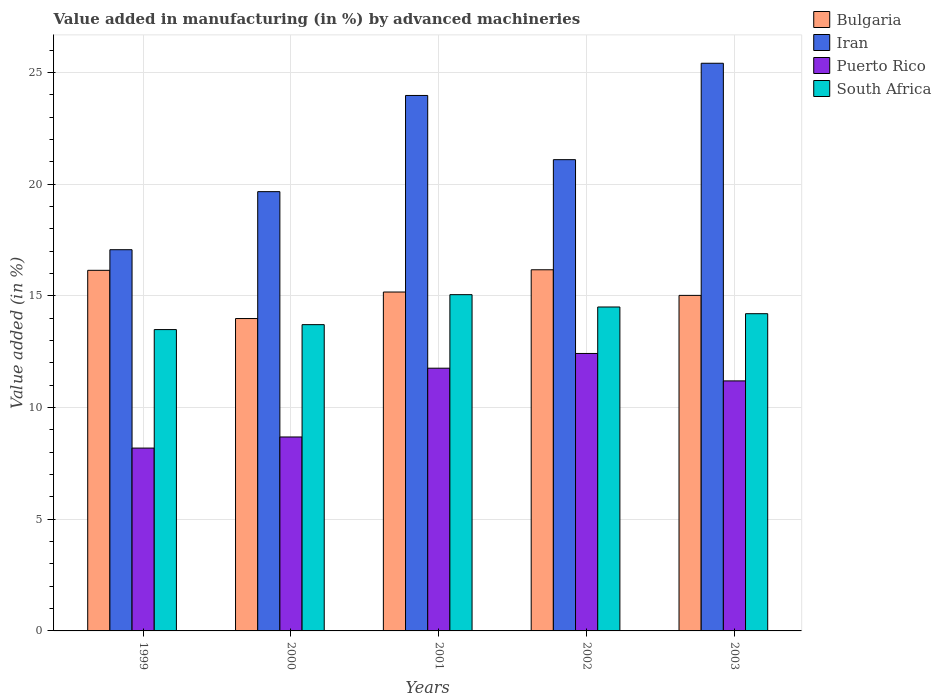How many different coloured bars are there?
Your answer should be very brief. 4. What is the label of the 5th group of bars from the left?
Provide a succinct answer. 2003. In how many cases, is the number of bars for a given year not equal to the number of legend labels?
Provide a short and direct response. 0. What is the percentage of value added in manufacturing by advanced machineries in Iran in 2002?
Ensure brevity in your answer.  21.1. Across all years, what is the maximum percentage of value added in manufacturing by advanced machineries in South Africa?
Ensure brevity in your answer.  15.05. Across all years, what is the minimum percentage of value added in manufacturing by advanced machineries in Puerto Rico?
Your answer should be compact. 8.19. In which year was the percentage of value added in manufacturing by advanced machineries in South Africa minimum?
Give a very brief answer. 1999. What is the total percentage of value added in manufacturing by advanced machineries in Puerto Rico in the graph?
Give a very brief answer. 52.25. What is the difference between the percentage of value added in manufacturing by advanced machineries in South Africa in 2001 and that in 2003?
Offer a very short reply. 0.85. What is the difference between the percentage of value added in manufacturing by advanced machineries in Iran in 2000 and the percentage of value added in manufacturing by advanced machineries in South Africa in 1999?
Provide a succinct answer. 6.18. What is the average percentage of value added in manufacturing by advanced machineries in South Africa per year?
Provide a succinct answer. 14.19. In the year 2000, what is the difference between the percentage of value added in manufacturing by advanced machineries in South Africa and percentage of value added in manufacturing by advanced machineries in Puerto Rico?
Your response must be concise. 5.03. What is the ratio of the percentage of value added in manufacturing by advanced machineries in Iran in 2000 to that in 2001?
Offer a very short reply. 0.82. Is the percentage of value added in manufacturing by advanced machineries in Puerto Rico in 1999 less than that in 2003?
Your response must be concise. Yes. What is the difference between the highest and the second highest percentage of value added in manufacturing by advanced machineries in South Africa?
Your response must be concise. 0.55. What is the difference between the highest and the lowest percentage of value added in manufacturing by advanced machineries in Bulgaria?
Keep it short and to the point. 2.18. In how many years, is the percentage of value added in manufacturing by advanced machineries in Puerto Rico greater than the average percentage of value added in manufacturing by advanced machineries in Puerto Rico taken over all years?
Your response must be concise. 3. Is the sum of the percentage of value added in manufacturing by advanced machineries in Iran in 2000 and 2002 greater than the maximum percentage of value added in manufacturing by advanced machineries in Puerto Rico across all years?
Provide a succinct answer. Yes. What does the 3rd bar from the left in 2001 represents?
Offer a very short reply. Puerto Rico. What does the 1st bar from the right in 1999 represents?
Provide a short and direct response. South Africa. Is it the case that in every year, the sum of the percentage of value added in manufacturing by advanced machineries in Iran and percentage of value added in manufacturing by advanced machineries in Bulgaria is greater than the percentage of value added in manufacturing by advanced machineries in South Africa?
Provide a short and direct response. Yes. Are all the bars in the graph horizontal?
Offer a terse response. No. Are the values on the major ticks of Y-axis written in scientific E-notation?
Provide a short and direct response. No. Where does the legend appear in the graph?
Give a very brief answer. Top right. What is the title of the graph?
Your response must be concise. Value added in manufacturing (in %) by advanced machineries. Does "Mauritius" appear as one of the legend labels in the graph?
Give a very brief answer. No. What is the label or title of the X-axis?
Ensure brevity in your answer.  Years. What is the label or title of the Y-axis?
Provide a succinct answer. Value added (in %). What is the Value added (in %) in Bulgaria in 1999?
Your answer should be compact. 16.14. What is the Value added (in %) of Iran in 1999?
Provide a short and direct response. 17.07. What is the Value added (in %) in Puerto Rico in 1999?
Offer a terse response. 8.19. What is the Value added (in %) of South Africa in 1999?
Your response must be concise. 13.49. What is the Value added (in %) of Bulgaria in 2000?
Offer a very short reply. 13.99. What is the Value added (in %) of Iran in 2000?
Your response must be concise. 19.67. What is the Value added (in %) of Puerto Rico in 2000?
Provide a short and direct response. 8.68. What is the Value added (in %) of South Africa in 2000?
Offer a very short reply. 13.71. What is the Value added (in %) in Bulgaria in 2001?
Offer a terse response. 15.17. What is the Value added (in %) in Iran in 2001?
Provide a short and direct response. 23.97. What is the Value added (in %) in Puerto Rico in 2001?
Make the answer very short. 11.76. What is the Value added (in %) of South Africa in 2001?
Give a very brief answer. 15.05. What is the Value added (in %) in Bulgaria in 2002?
Your response must be concise. 16.17. What is the Value added (in %) of Iran in 2002?
Make the answer very short. 21.1. What is the Value added (in %) of Puerto Rico in 2002?
Provide a succinct answer. 12.42. What is the Value added (in %) in South Africa in 2002?
Provide a succinct answer. 14.5. What is the Value added (in %) in Bulgaria in 2003?
Make the answer very short. 15.02. What is the Value added (in %) of Iran in 2003?
Give a very brief answer. 25.41. What is the Value added (in %) of Puerto Rico in 2003?
Keep it short and to the point. 11.19. What is the Value added (in %) of South Africa in 2003?
Keep it short and to the point. 14.2. Across all years, what is the maximum Value added (in %) in Bulgaria?
Give a very brief answer. 16.17. Across all years, what is the maximum Value added (in %) of Iran?
Give a very brief answer. 25.41. Across all years, what is the maximum Value added (in %) in Puerto Rico?
Your response must be concise. 12.42. Across all years, what is the maximum Value added (in %) in South Africa?
Ensure brevity in your answer.  15.05. Across all years, what is the minimum Value added (in %) of Bulgaria?
Offer a terse response. 13.99. Across all years, what is the minimum Value added (in %) in Iran?
Keep it short and to the point. 17.07. Across all years, what is the minimum Value added (in %) in Puerto Rico?
Provide a short and direct response. 8.19. Across all years, what is the minimum Value added (in %) of South Africa?
Offer a terse response. 13.49. What is the total Value added (in %) of Bulgaria in the graph?
Your answer should be very brief. 76.49. What is the total Value added (in %) of Iran in the graph?
Keep it short and to the point. 107.22. What is the total Value added (in %) in Puerto Rico in the graph?
Offer a very short reply. 52.25. What is the total Value added (in %) of South Africa in the graph?
Your answer should be compact. 70.96. What is the difference between the Value added (in %) in Bulgaria in 1999 and that in 2000?
Your response must be concise. 2.16. What is the difference between the Value added (in %) of Iran in 1999 and that in 2000?
Your response must be concise. -2.6. What is the difference between the Value added (in %) of Puerto Rico in 1999 and that in 2000?
Offer a terse response. -0.5. What is the difference between the Value added (in %) in South Africa in 1999 and that in 2000?
Provide a short and direct response. -0.22. What is the difference between the Value added (in %) in Bulgaria in 1999 and that in 2001?
Offer a very short reply. 0.97. What is the difference between the Value added (in %) of Iran in 1999 and that in 2001?
Provide a succinct answer. -6.91. What is the difference between the Value added (in %) of Puerto Rico in 1999 and that in 2001?
Make the answer very short. -3.58. What is the difference between the Value added (in %) in South Africa in 1999 and that in 2001?
Offer a terse response. -1.56. What is the difference between the Value added (in %) in Bulgaria in 1999 and that in 2002?
Offer a very short reply. -0.02. What is the difference between the Value added (in %) in Iran in 1999 and that in 2002?
Ensure brevity in your answer.  -4.03. What is the difference between the Value added (in %) of Puerto Rico in 1999 and that in 2002?
Make the answer very short. -4.24. What is the difference between the Value added (in %) in South Africa in 1999 and that in 2002?
Your answer should be very brief. -1.01. What is the difference between the Value added (in %) of Bulgaria in 1999 and that in 2003?
Ensure brevity in your answer.  1.12. What is the difference between the Value added (in %) in Iran in 1999 and that in 2003?
Your answer should be very brief. -8.35. What is the difference between the Value added (in %) of Puerto Rico in 1999 and that in 2003?
Provide a succinct answer. -3.01. What is the difference between the Value added (in %) in South Africa in 1999 and that in 2003?
Your response must be concise. -0.71. What is the difference between the Value added (in %) of Bulgaria in 2000 and that in 2001?
Your answer should be very brief. -1.19. What is the difference between the Value added (in %) of Iran in 2000 and that in 2001?
Provide a short and direct response. -4.31. What is the difference between the Value added (in %) in Puerto Rico in 2000 and that in 2001?
Provide a succinct answer. -3.08. What is the difference between the Value added (in %) of South Africa in 2000 and that in 2001?
Give a very brief answer. -1.34. What is the difference between the Value added (in %) of Bulgaria in 2000 and that in 2002?
Provide a succinct answer. -2.18. What is the difference between the Value added (in %) of Iran in 2000 and that in 2002?
Offer a very short reply. -1.43. What is the difference between the Value added (in %) of Puerto Rico in 2000 and that in 2002?
Provide a succinct answer. -3.74. What is the difference between the Value added (in %) in South Africa in 2000 and that in 2002?
Give a very brief answer. -0.79. What is the difference between the Value added (in %) in Bulgaria in 2000 and that in 2003?
Provide a succinct answer. -1.04. What is the difference between the Value added (in %) of Iran in 2000 and that in 2003?
Provide a succinct answer. -5.75. What is the difference between the Value added (in %) of Puerto Rico in 2000 and that in 2003?
Give a very brief answer. -2.51. What is the difference between the Value added (in %) of South Africa in 2000 and that in 2003?
Ensure brevity in your answer.  -0.49. What is the difference between the Value added (in %) in Bulgaria in 2001 and that in 2002?
Make the answer very short. -1. What is the difference between the Value added (in %) in Iran in 2001 and that in 2002?
Offer a very short reply. 2.87. What is the difference between the Value added (in %) in Puerto Rico in 2001 and that in 2002?
Offer a terse response. -0.66. What is the difference between the Value added (in %) in South Africa in 2001 and that in 2002?
Your answer should be compact. 0.55. What is the difference between the Value added (in %) in Bulgaria in 2001 and that in 2003?
Offer a very short reply. 0.15. What is the difference between the Value added (in %) of Iran in 2001 and that in 2003?
Provide a short and direct response. -1.44. What is the difference between the Value added (in %) in Puerto Rico in 2001 and that in 2003?
Keep it short and to the point. 0.57. What is the difference between the Value added (in %) of South Africa in 2001 and that in 2003?
Your answer should be very brief. 0.85. What is the difference between the Value added (in %) in Bulgaria in 2002 and that in 2003?
Offer a very short reply. 1.15. What is the difference between the Value added (in %) in Iran in 2002 and that in 2003?
Your answer should be compact. -4.32. What is the difference between the Value added (in %) of Puerto Rico in 2002 and that in 2003?
Offer a very short reply. 1.23. What is the difference between the Value added (in %) in South Africa in 2002 and that in 2003?
Your answer should be very brief. 0.3. What is the difference between the Value added (in %) in Bulgaria in 1999 and the Value added (in %) in Iran in 2000?
Your answer should be compact. -3.52. What is the difference between the Value added (in %) in Bulgaria in 1999 and the Value added (in %) in Puerto Rico in 2000?
Provide a short and direct response. 7.46. What is the difference between the Value added (in %) in Bulgaria in 1999 and the Value added (in %) in South Africa in 2000?
Your response must be concise. 2.43. What is the difference between the Value added (in %) in Iran in 1999 and the Value added (in %) in Puerto Rico in 2000?
Offer a very short reply. 8.38. What is the difference between the Value added (in %) in Iran in 1999 and the Value added (in %) in South Africa in 2000?
Your answer should be compact. 3.35. What is the difference between the Value added (in %) of Puerto Rico in 1999 and the Value added (in %) of South Africa in 2000?
Offer a very short reply. -5.53. What is the difference between the Value added (in %) of Bulgaria in 1999 and the Value added (in %) of Iran in 2001?
Keep it short and to the point. -7.83. What is the difference between the Value added (in %) of Bulgaria in 1999 and the Value added (in %) of Puerto Rico in 2001?
Offer a terse response. 4.38. What is the difference between the Value added (in %) of Bulgaria in 1999 and the Value added (in %) of South Africa in 2001?
Make the answer very short. 1.09. What is the difference between the Value added (in %) in Iran in 1999 and the Value added (in %) in Puerto Rico in 2001?
Your answer should be compact. 5.3. What is the difference between the Value added (in %) of Iran in 1999 and the Value added (in %) of South Africa in 2001?
Ensure brevity in your answer.  2.01. What is the difference between the Value added (in %) of Puerto Rico in 1999 and the Value added (in %) of South Africa in 2001?
Provide a succinct answer. -6.87. What is the difference between the Value added (in %) in Bulgaria in 1999 and the Value added (in %) in Iran in 2002?
Your response must be concise. -4.95. What is the difference between the Value added (in %) of Bulgaria in 1999 and the Value added (in %) of Puerto Rico in 2002?
Provide a short and direct response. 3.72. What is the difference between the Value added (in %) in Bulgaria in 1999 and the Value added (in %) in South Africa in 2002?
Provide a short and direct response. 1.64. What is the difference between the Value added (in %) of Iran in 1999 and the Value added (in %) of Puerto Rico in 2002?
Offer a terse response. 4.64. What is the difference between the Value added (in %) of Iran in 1999 and the Value added (in %) of South Africa in 2002?
Provide a short and direct response. 2.56. What is the difference between the Value added (in %) in Puerto Rico in 1999 and the Value added (in %) in South Africa in 2002?
Your answer should be very brief. -6.32. What is the difference between the Value added (in %) in Bulgaria in 1999 and the Value added (in %) in Iran in 2003?
Offer a very short reply. -9.27. What is the difference between the Value added (in %) in Bulgaria in 1999 and the Value added (in %) in Puerto Rico in 2003?
Your response must be concise. 4.95. What is the difference between the Value added (in %) in Bulgaria in 1999 and the Value added (in %) in South Africa in 2003?
Provide a short and direct response. 1.94. What is the difference between the Value added (in %) in Iran in 1999 and the Value added (in %) in Puerto Rico in 2003?
Keep it short and to the point. 5.87. What is the difference between the Value added (in %) of Iran in 1999 and the Value added (in %) of South Africa in 2003?
Offer a very short reply. 2.86. What is the difference between the Value added (in %) in Puerto Rico in 1999 and the Value added (in %) in South Africa in 2003?
Offer a terse response. -6.02. What is the difference between the Value added (in %) in Bulgaria in 2000 and the Value added (in %) in Iran in 2001?
Make the answer very short. -9.99. What is the difference between the Value added (in %) in Bulgaria in 2000 and the Value added (in %) in Puerto Rico in 2001?
Ensure brevity in your answer.  2.22. What is the difference between the Value added (in %) in Bulgaria in 2000 and the Value added (in %) in South Africa in 2001?
Your answer should be compact. -1.07. What is the difference between the Value added (in %) of Iran in 2000 and the Value added (in %) of Puerto Rico in 2001?
Give a very brief answer. 7.9. What is the difference between the Value added (in %) of Iran in 2000 and the Value added (in %) of South Africa in 2001?
Offer a very short reply. 4.61. What is the difference between the Value added (in %) in Puerto Rico in 2000 and the Value added (in %) in South Africa in 2001?
Provide a succinct answer. -6.37. What is the difference between the Value added (in %) in Bulgaria in 2000 and the Value added (in %) in Iran in 2002?
Offer a terse response. -7.11. What is the difference between the Value added (in %) in Bulgaria in 2000 and the Value added (in %) in Puerto Rico in 2002?
Offer a very short reply. 1.56. What is the difference between the Value added (in %) in Bulgaria in 2000 and the Value added (in %) in South Africa in 2002?
Your answer should be very brief. -0.52. What is the difference between the Value added (in %) in Iran in 2000 and the Value added (in %) in Puerto Rico in 2002?
Ensure brevity in your answer.  7.24. What is the difference between the Value added (in %) of Iran in 2000 and the Value added (in %) of South Africa in 2002?
Provide a succinct answer. 5.16. What is the difference between the Value added (in %) of Puerto Rico in 2000 and the Value added (in %) of South Africa in 2002?
Keep it short and to the point. -5.82. What is the difference between the Value added (in %) in Bulgaria in 2000 and the Value added (in %) in Iran in 2003?
Offer a very short reply. -11.43. What is the difference between the Value added (in %) in Bulgaria in 2000 and the Value added (in %) in Puerto Rico in 2003?
Offer a very short reply. 2.79. What is the difference between the Value added (in %) of Bulgaria in 2000 and the Value added (in %) of South Africa in 2003?
Provide a succinct answer. -0.22. What is the difference between the Value added (in %) in Iran in 2000 and the Value added (in %) in Puerto Rico in 2003?
Provide a succinct answer. 8.47. What is the difference between the Value added (in %) in Iran in 2000 and the Value added (in %) in South Africa in 2003?
Offer a very short reply. 5.46. What is the difference between the Value added (in %) of Puerto Rico in 2000 and the Value added (in %) of South Africa in 2003?
Provide a short and direct response. -5.52. What is the difference between the Value added (in %) in Bulgaria in 2001 and the Value added (in %) in Iran in 2002?
Offer a terse response. -5.93. What is the difference between the Value added (in %) in Bulgaria in 2001 and the Value added (in %) in Puerto Rico in 2002?
Keep it short and to the point. 2.75. What is the difference between the Value added (in %) in Bulgaria in 2001 and the Value added (in %) in South Africa in 2002?
Give a very brief answer. 0.67. What is the difference between the Value added (in %) of Iran in 2001 and the Value added (in %) of Puerto Rico in 2002?
Make the answer very short. 11.55. What is the difference between the Value added (in %) in Iran in 2001 and the Value added (in %) in South Africa in 2002?
Give a very brief answer. 9.47. What is the difference between the Value added (in %) in Puerto Rico in 2001 and the Value added (in %) in South Africa in 2002?
Offer a very short reply. -2.74. What is the difference between the Value added (in %) in Bulgaria in 2001 and the Value added (in %) in Iran in 2003?
Ensure brevity in your answer.  -10.24. What is the difference between the Value added (in %) in Bulgaria in 2001 and the Value added (in %) in Puerto Rico in 2003?
Your answer should be compact. 3.98. What is the difference between the Value added (in %) of Bulgaria in 2001 and the Value added (in %) of South Africa in 2003?
Keep it short and to the point. 0.97. What is the difference between the Value added (in %) of Iran in 2001 and the Value added (in %) of Puerto Rico in 2003?
Give a very brief answer. 12.78. What is the difference between the Value added (in %) of Iran in 2001 and the Value added (in %) of South Africa in 2003?
Make the answer very short. 9.77. What is the difference between the Value added (in %) of Puerto Rico in 2001 and the Value added (in %) of South Africa in 2003?
Ensure brevity in your answer.  -2.44. What is the difference between the Value added (in %) in Bulgaria in 2002 and the Value added (in %) in Iran in 2003?
Keep it short and to the point. -9.25. What is the difference between the Value added (in %) in Bulgaria in 2002 and the Value added (in %) in Puerto Rico in 2003?
Provide a short and direct response. 4.98. What is the difference between the Value added (in %) in Bulgaria in 2002 and the Value added (in %) in South Africa in 2003?
Your answer should be very brief. 1.97. What is the difference between the Value added (in %) in Iran in 2002 and the Value added (in %) in Puerto Rico in 2003?
Give a very brief answer. 9.9. What is the difference between the Value added (in %) in Iran in 2002 and the Value added (in %) in South Africa in 2003?
Your response must be concise. 6.9. What is the difference between the Value added (in %) in Puerto Rico in 2002 and the Value added (in %) in South Africa in 2003?
Your response must be concise. -1.78. What is the average Value added (in %) of Bulgaria per year?
Make the answer very short. 15.3. What is the average Value added (in %) in Iran per year?
Ensure brevity in your answer.  21.44. What is the average Value added (in %) in Puerto Rico per year?
Give a very brief answer. 10.45. What is the average Value added (in %) in South Africa per year?
Your answer should be very brief. 14.19. In the year 1999, what is the difference between the Value added (in %) of Bulgaria and Value added (in %) of Iran?
Ensure brevity in your answer.  -0.92. In the year 1999, what is the difference between the Value added (in %) in Bulgaria and Value added (in %) in Puerto Rico?
Your response must be concise. 7.96. In the year 1999, what is the difference between the Value added (in %) in Bulgaria and Value added (in %) in South Africa?
Keep it short and to the point. 2.65. In the year 1999, what is the difference between the Value added (in %) in Iran and Value added (in %) in Puerto Rico?
Offer a terse response. 8.88. In the year 1999, what is the difference between the Value added (in %) in Iran and Value added (in %) in South Africa?
Your answer should be very brief. 3.58. In the year 1999, what is the difference between the Value added (in %) of Puerto Rico and Value added (in %) of South Africa?
Your answer should be very brief. -5.31. In the year 2000, what is the difference between the Value added (in %) in Bulgaria and Value added (in %) in Iran?
Your answer should be compact. -5.68. In the year 2000, what is the difference between the Value added (in %) of Bulgaria and Value added (in %) of Puerto Rico?
Make the answer very short. 5.3. In the year 2000, what is the difference between the Value added (in %) of Bulgaria and Value added (in %) of South Africa?
Offer a very short reply. 0.27. In the year 2000, what is the difference between the Value added (in %) of Iran and Value added (in %) of Puerto Rico?
Offer a very short reply. 10.98. In the year 2000, what is the difference between the Value added (in %) in Iran and Value added (in %) in South Africa?
Ensure brevity in your answer.  5.95. In the year 2000, what is the difference between the Value added (in %) of Puerto Rico and Value added (in %) of South Africa?
Your answer should be compact. -5.03. In the year 2001, what is the difference between the Value added (in %) of Bulgaria and Value added (in %) of Iran?
Keep it short and to the point. -8.8. In the year 2001, what is the difference between the Value added (in %) in Bulgaria and Value added (in %) in Puerto Rico?
Your answer should be compact. 3.41. In the year 2001, what is the difference between the Value added (in %) of Bulgaria and Value added (in %) of South Africa?
Make the answer very short. 0.12. In the year 2001, what is the difference between the Value added (in %) in Iran and Value added (in %) in Puerto Rico?
Provide a short and direct response. 12.21. In the year 2001, what is the difference between the Value added (in %) of Iran and Value added (in %) of South Africa?
Keep it short and to the point. 8.92. In the year 2001, what is the difference between the Value added (in %) of Puerto Rico and Value added (in %) of South Africa?
Your response must be concise. -3.29. In the year 2002, what is the difference between the Value added (in %) of Bulgaria and Value added (in %) of Iran?
Your answer should be very brief. -4.93. In the year 2002, what is the difference between the Value added (in %) in Bulgaria and Value added (in %) in Puerto Rico?
Give a very brief answer. 3.75. In the year 2002, what is the difference between the Value added (in %) in Bulgaria and Value added (in %) in South Africa?
Provide a short and direct response. 1.67. In the year 2002, what is the difference between the Value added (in %) in Iran and Value added (in %) in Puerto Rico?
Your answer should be compact. 8.68. In the year 2002, what is the difference between the Value added (in %) in Iran and Value added (in %) in South Africa?
Your answer should be very brief. 6.6. In the year 2002, what is the difference between the Value added (in %) in Puerto Rico and Value added (in %) in South Africa?
Your answer should be very brief. -2.08. In the year 2003, what is the difference between the Value added (in %) in Bulgaria and Value added (in %) in Iran?
Ensure brevity in your answer.  -10.39. In the year 2003, what is the difference between the Value added (in %) in Bulgaria and Value added (in %) in Puerto Rico?
Ensure brevity in your answer.  3.83. In the year 2003, what is the difference between the Value added (in %) of Bulgaria and Value added (in %) of South Africa?
Ensure brevity in your answer.  0.82. In the year 2003, what is the difference between the Value added (in %) of Iran and Value added (in %) of Puerto Rico?
Provide a succinct answer. 14.22. In the year 2003, what is the difference between the Value added (in %) of Iran and Value added (in %) of South Africa?
Your response must be concise. 11.21. In the year 2003, what is the difference between the Value added (in %) in Puerto Rico and Value added (in %) in South Africa?
Your answer should be compact. -3.01. What is the ratio of the Value added (in %) of Bulgaria in 1999 to that in 2000?
Your answer should be compact. 1.15. What is the ratio of the Value added (in %) in Iran in 1999 to that in 2000?
Provide a succinct answer. 0.87. What is the ratio of the Value added (in %) of Puerto Rico in 1999 to that in 2000?
Your response must be concise. 0.94. What is the ratio of the Value added (in %) in South Africa in 1999 to that in 2000?
Keep it short and to the point. 0.98. What is the ratio of the Value added (in %) of Bulgaria in 1999 to that in 2001?
Keep it short and to the point. 1.06. What is the ratio of the Value added (in %) of Iran in 1999 to that in 2001?
Keep it short and to the point. 0.71. What is the ratio of the Value added (in %) of Puerto Rico in 1999 to that in 2001?
Your answer should be compact. 0.7. What is the ratio of the Value added (in %) of South Africa in 1999 to that in 2001?
Provide a short and direct response. 0.9. What is the ratio of the Value added (in %) of Iran in 1999 to that in 2002?
Provide a short and direct response. 0.81. What is the ratio of the Value added (in %) in Puerto Rico in 1999 to that in 2002?
Give a very brief answer. 0.66. What is the ratio of the Value added (in %) of South Africa in 1999 to that in 2002?
Provide a short and direct response. 0.93. What is the ratio of the Value added (in %) of Bulgaria in 1999 to that in 2003?
Ensure brevity in your answer.  1.07. What is the ratio of the Value added (in %) in Iran in 1999 to that in 2003?
Keep it short and to the point. 0.67. What is the ratio of the Value added (in %) of Puerto Rico in 1999 to that in 2003?
Offer a very short reply. 0.73. What is the ratio of the Value added (in %) in South Africa in 1999 to that in 2003?
Provide a succinct answer. 0.95. What is the ratio of the Value added (in %) in Bulgaria in 2000 to that in 2001?
Give a very brief answer. 0.92. What is the ratio of the Value added (in %) in Iran in 2000 to that in 2001?
Your answer should be very brief. 0.82. What is the ratio of the Value added (in %) in Puerto Rico in 2000 to that in 2001?
Provide a short and direct response. 0.74. What is the ratio of the Value added (in %) in South Africa in 2000 to that in 2001?
Keep it short and to the point. 0.91. What is the ratio of the Value added (in %) in Bulgaria in 2000 to that in 2002?
Make the answer very short. 0.86. What is the ratio of the Value added (in %) of Iran in 2000 to that in 2002?
Ensure brevity in your answer.  0.93. What is the ratio of the Value added (in %) in Puerto Rico in 2000 to that in 2002?
Offer a very short reply. 0.7. What is the ratio of the Value added (in %) of South Africa in 2000 to that in 2002?
Provide a short and direct response. 0.95. What is the ratio of the Value added (in %) in Iran in 2000 to that in 2003?
Offer a terse response. 0.77. What is the ratio of the Value added (in %) in Puerto Rico in 2000 to that in 2003?
Offer a terse response. 0.78. What is the ratio of the Value added (in %) in South Africa in 2000 to that in 2003?
Your answer should be compact. 0.97. What is the ratio of the Value added (in %) in Bulgaria in 2001 to that in 2002?
Keep it short and to the point. 0.94. What is the ratio of the Value added (in %) in Iran in 2001 to that in 2002?
Make the answer very short. 1.14. What is the ratio of the Value added (in %) of Puerto Rico in 2001 to that in 2002?
Make the answer very short. 0.95. What is the ratio of the Value added (in %) of South Africa in 2001 to that in 2002?
Give a very brief answer. 1.04. What is the ratio of the Value added (in %) of Iran in 2001 to that in 2003?
Keep it short and to the point. 0.94. What is the ratio of the Value added (in %) of Puerto Rico in 2001 to that in 2003?
Offer a terse response. 1.05. What is the ratio of the Value added (in %) of South Africa in 2001 to that in 2003?
Offer a terse response. 1.06. What is the ratio of the Value added (in %) in Bulgaria in 2002 to that in 2003?
Provide a short and direct response. 1.08. What is the ratio of the Value added (in %) in Iran in 2002 to that in 2003?
Your answer should be very brief. 0.83. What is the ratio of the Value added (in %) in Puerto Rico in 2002 to that in 2003?
Provide a short and direct response. 1.11. What is the ratio of the Value added (in %) of South Africa in 2002 to that in 2003?
Make the answer very short. 1.02. What is the difference between the highest and the second highest Value added (in %) in Bulgaria?
Your answer should be very brief. 0.02. What is the difference between the highest and the second highest Value added (in %) of Iran?
Make the answer very short. 1.44. What is the difference between the highest and the second highest Value added (in %) in Puerto Rico?
Offer a very short reply. 0.66. What is the difference between the highest and the second highest Value added (in %) in South Africa?
Your answer should be compact. 0.55. What is the difference between the highest and the lowest Value added (in %) in Bulgaria?
Provide a short and direct response. 2.18. What is the difference between the highest and the lowest Value added (in %) of Iran?
Offer a terse response. 8.35. What is the difference between the highest and the lowest Value added (in %) of Puerto Rico?
Your response must be concise. 4.24. What is the difference between the highest and the lowest Value added (in %) in South Africa?
Provide a short and direct response. 1.56. 